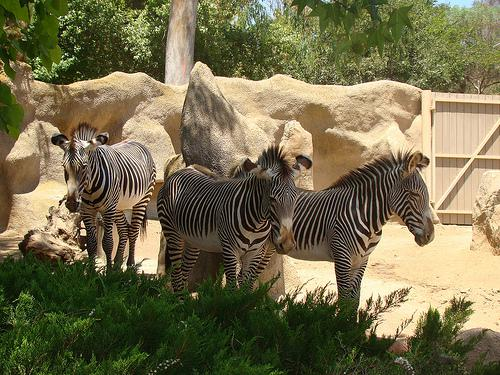Question: what are they?
Choices:
A. Cats.
B. Zebras.
C. Dogs.
D. Lions.
Answer with the letter. Answer: B Question: who is present?
Choices:
A. Nobody.
B. Mom.
C. Dad.
D. Girl.
Answer with the letter. Answer: A Question: where was this photo taken?
Choices:
A. On the beach.
B. In the yard.
C. In a house.
D. At a zoo.
Answer with the letter. Answer: D 